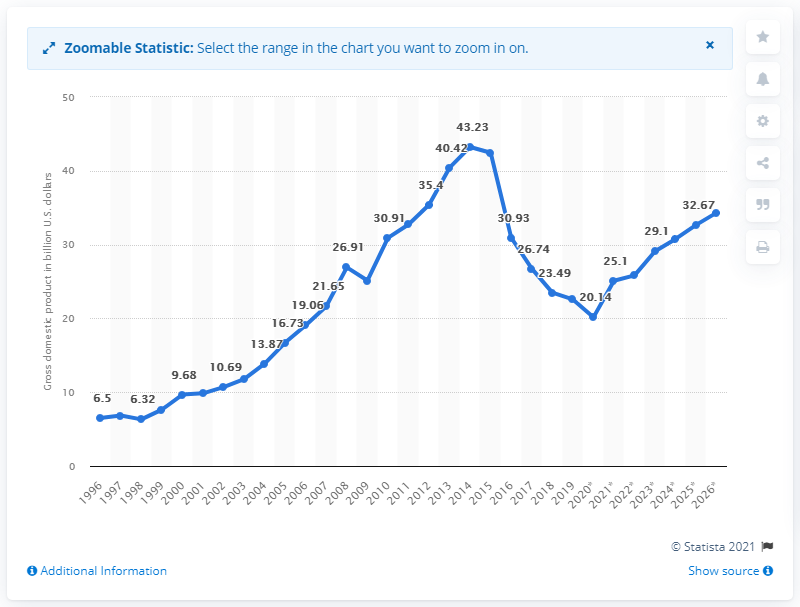Point out several critical features in this image. In 2019, Yemen's gross domestic product was 22.57. 